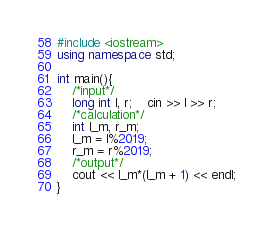Convert code to text. <code><loc_0><loc_0><loc_500><loc_500><_C++_>#include <iostream>
using namespace std;

int main(){
	/*input*/
	long int l, r;	cin >> l >> r; 
	/*calculation*/
	int l_m, r_m;
	l_m = l%2019;
	r_m = r%2019;
	/*output*/
	cout << l_m*(l_m + 1) << endl; 
}
</code> 